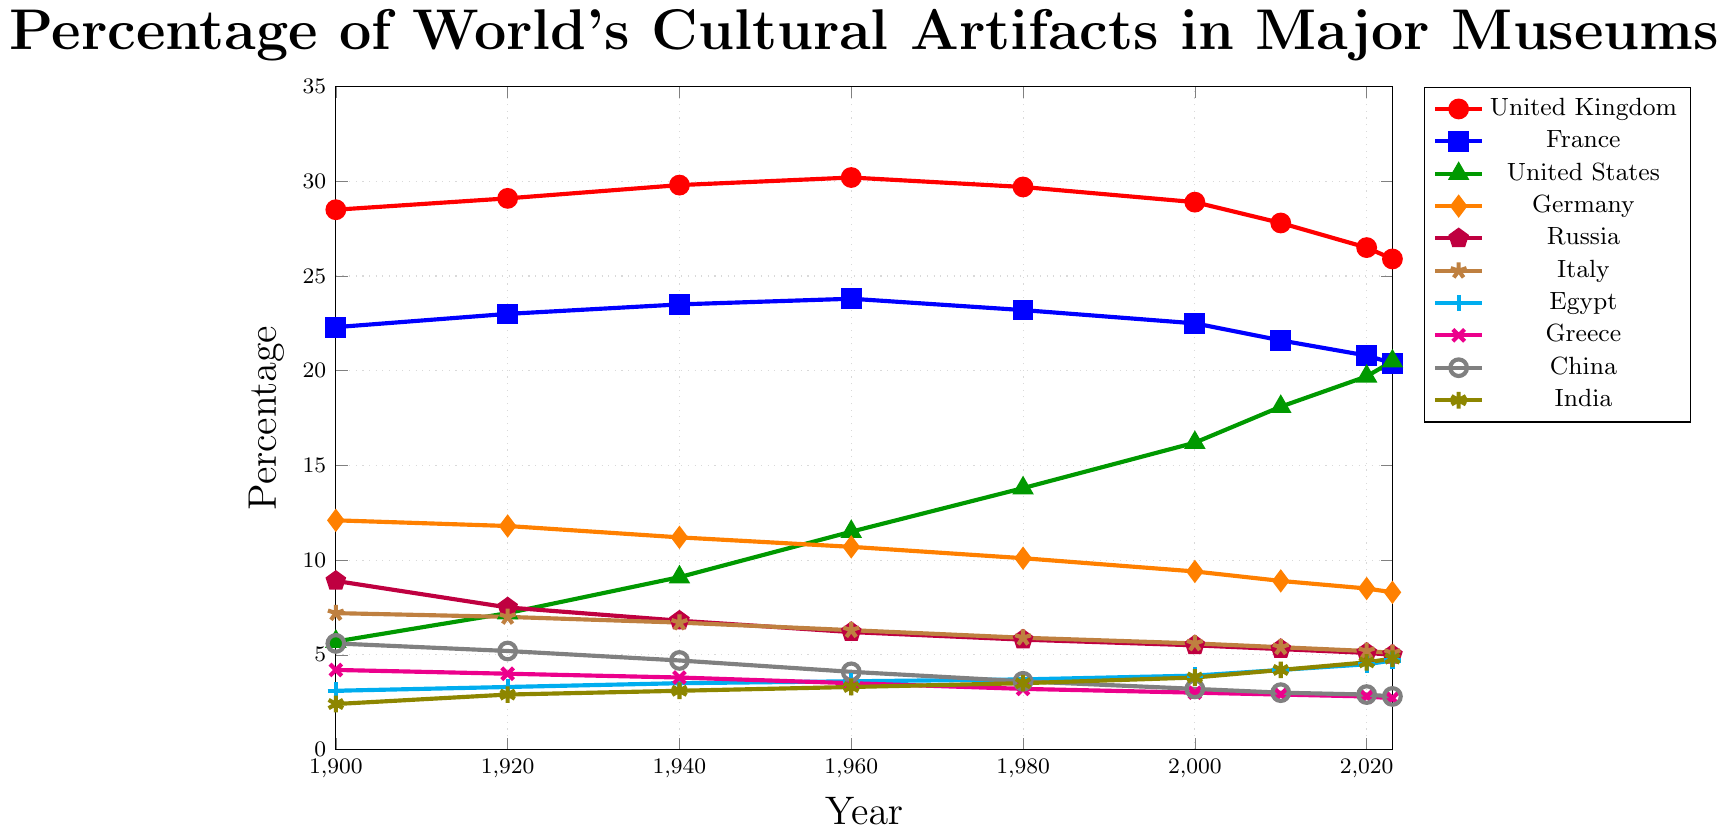What country has the highest percentage of the world's cultural artifacts in major museums in 2023? The highest percentage in 2023 belongs to the United Kingdom, as it maintains the top red line throughout the timeline despite a downward trend.
Answer: United Kingdom How does the percentage of cultural artifacts in the United States' major museums change from 1900 to 2023? The percentage increases steadily from 5.7% in 1900 to 20.5% in 2023 according to the data plot marked with a green triangle.
Answer: Increases Which country saw the most significant decrease in percentage share of cultural artifacts from 1900 to 2023? Russia's percentage decreased from 8.9% in 1900 to 5.0% in 2023, which is a significant decrease compared to other countries.
Answer: Russia Compare the percentages of France and Germany in 1940. Which country has more and by how much? In 1940, France has 23.5% and Germany has 11.2%. Subtract Germany's percentage from France's percentage: 23.5% - 11.2% = 12.3%.
Answer: France by 12.3% Between 1900 and 2023, which country has shown a consistent increase in its percentage share? The United States has shown a consistent increase in its percentage share from 5.7% in 1900 to 20.5% in 2023, indicated by the smooth upward trend of the green triangle line.
Answer: United States What is the difference in the percentage of cultural artifacts between Egypt and China in 2023? In 2023, Egypt's percentage is 4.7% and China's percentage is 2.8%. The difference is 4.7% - 2.8% = 1.9%.
Answer: 1.9% Which country had a nearly unchanged percentage between 1900 and 2023? Italy had a slight change from 7.2% in 1900 to 5.1% in 2023, indicating a relatively stable share throughout the period.
Answer: Italy Which country shows an overall declining trend from 1900 to 2023? Germany shows an overall decline from 12.1% in 1900 to 8.3% in 2023, displayed by the downward trend of the orange diamond line.
Answer: Germany Based on the visual plot, which year shows the maximum percentage of artifacts for the United Kingdom? The United Kingdom shows its peak percentage in 1960, reaching 30.2%, as seen where the highest point of the red line is located.
Answer: 1960 